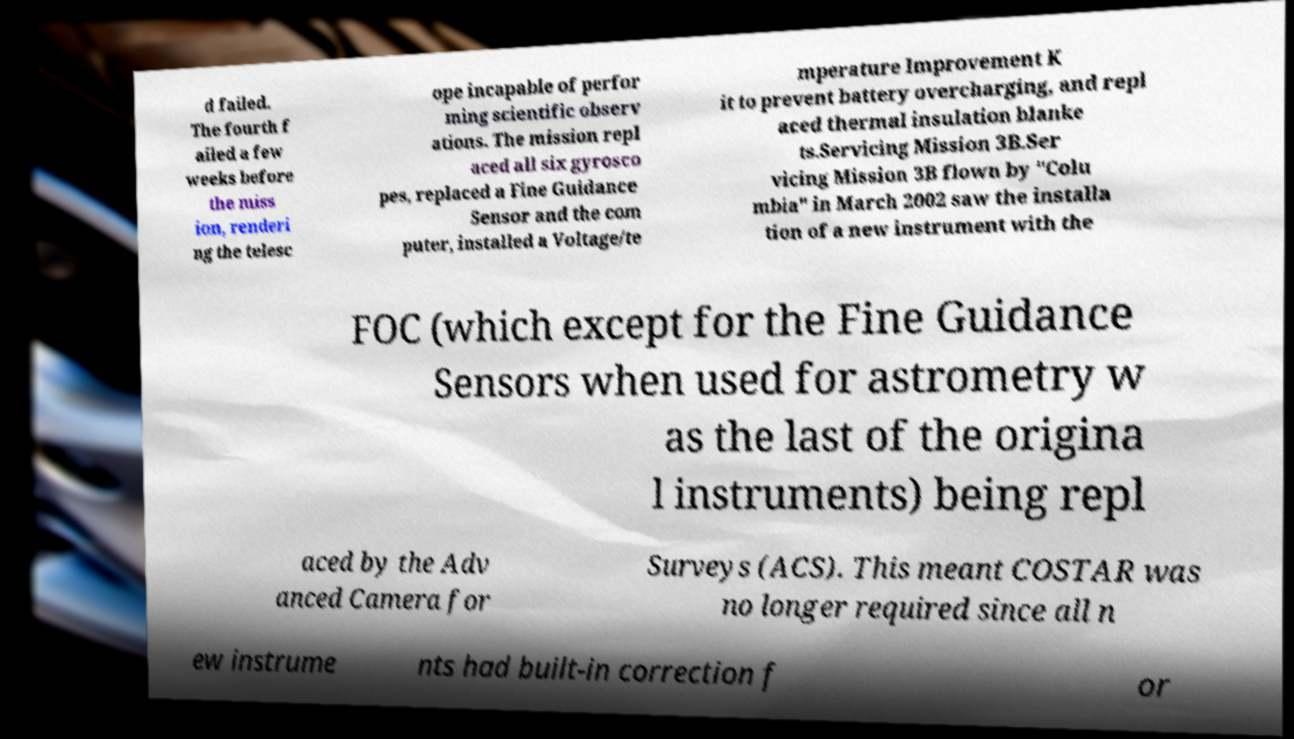I need the written content from this picture converted into text. Can you do that? d failed. The fourth f ailed a few weeks before the miss ion, renderi ng the telesc ope incapable of perfor ming scientific observ ations. The mission repl aced all six gyrosco pes, replaced a Fine Guidance Sensor and the com puter, installed a Voltage/te mperature Improvement K it to prevent battery overcharging, and repl aced thermal insulation blanke ts.Servicing Mission 3B.Ser vicing Mission 3B flown by "Colu mbia" in March 2002 saw the installa tion of a new instrument with the FOC (which except for the Fine Guidance Sensors when used for astrometry w as the last of the origina l instruments) being repl aced by the Adv anced Camera for Surveys (ACS). This meant COSTAR was no longer required since all n ew instrume nts had built-in correction f or 